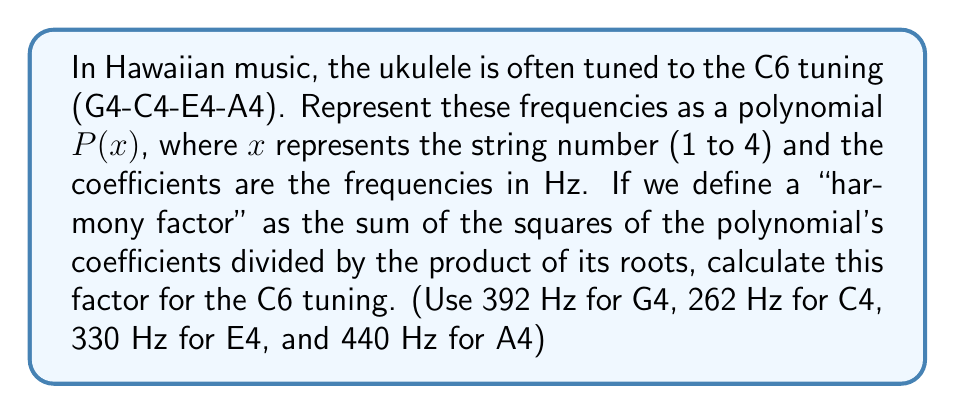Solve this math problem. 1) First, let's create the polynomial $P(x)$ using the given frequencies:
   $P(x) = 392x^3 + 262x^2 + 330x + 440$

2) The sum of the squares of the coefficients is:
   $S = 392^2 + 262^2 + 330^2 + 440^2 = 153664 + 68644 + 108900 + 193600 = 524808$

3) To find the roots of the polynomial, we would typically need to solve the equation $P(x) = 0$. However, for this problem, we don't need to actually solve for the roots. We can use Vieta's formulas to find their product.

4) The product of the roots, according to Vieta's formulas, is:
   $r_1 \cdot r_2 \cdot r_3 = -\frac{a_0}{a_3} = -\frac{440}{392} = -\frac{10}{9}$

5) The harmony factor is defined as:
   $H = \frac{\text{Sum of squares of coefficients}}{\text{Product of roots}}$

6) Substituting the values:
   $H = \frac{524808}{|-\frac{10}{9}|} = 524808 \cdot \frac{9}{10} = 472327.2$

Therefore, the harmony factor for the C6 tuning of the ukulele is 472327.2.
Answer: 472327.2 